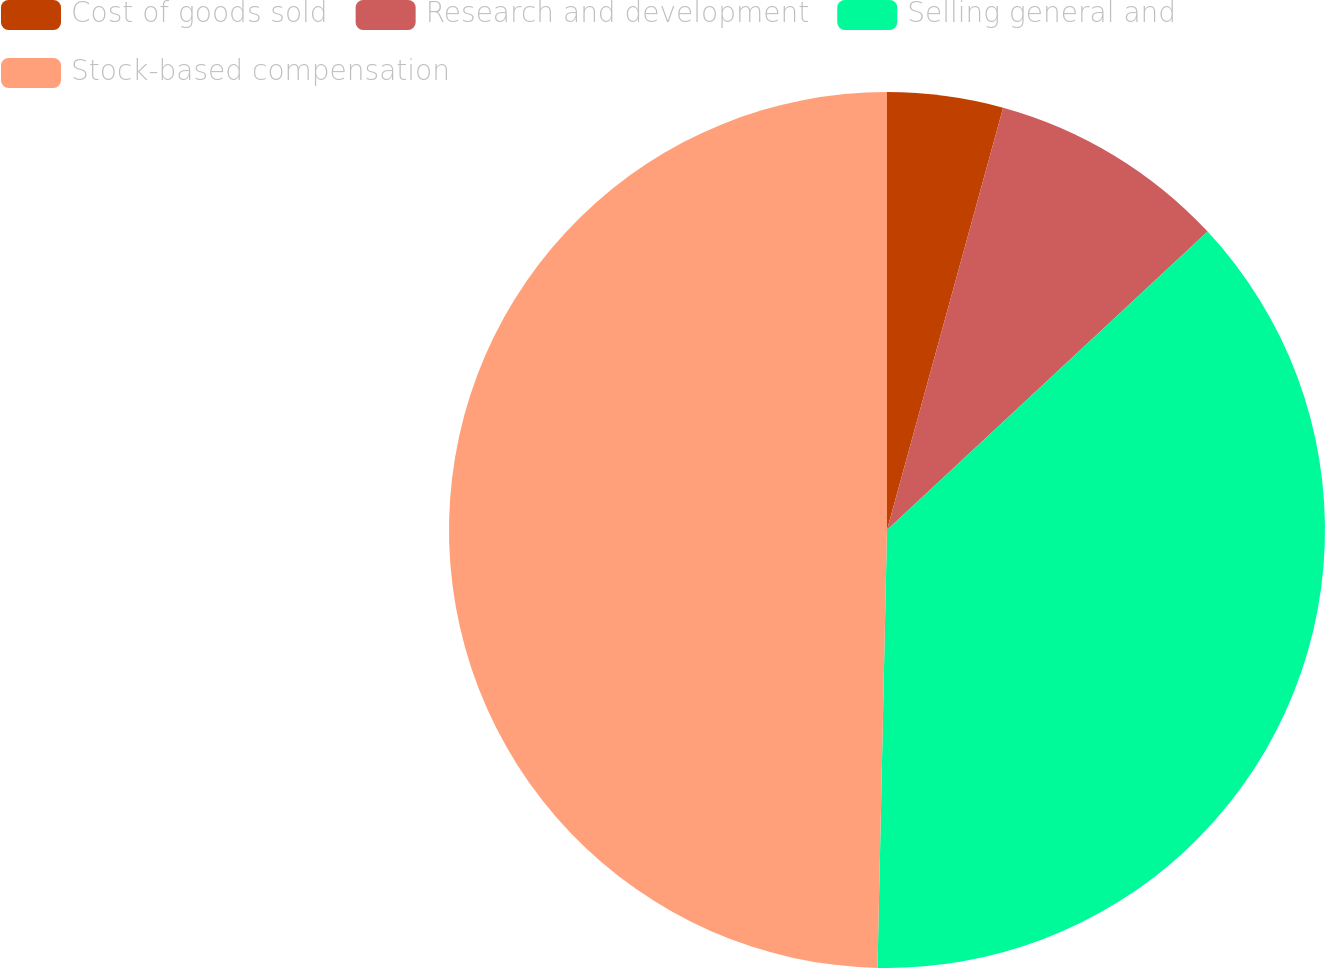Convert chart to OTSL. <chart><loc_0><loc_0><loc_500><loc_500><pie_chart><fcel>Cost of goods sold<fcel>Research and development<fcel>Selling general and<fcel>Stock-based compensation<nl><fcel>4.27%<fcel>8.8%<fcel>37.27%<fcel>49.65%<nl></chart> 